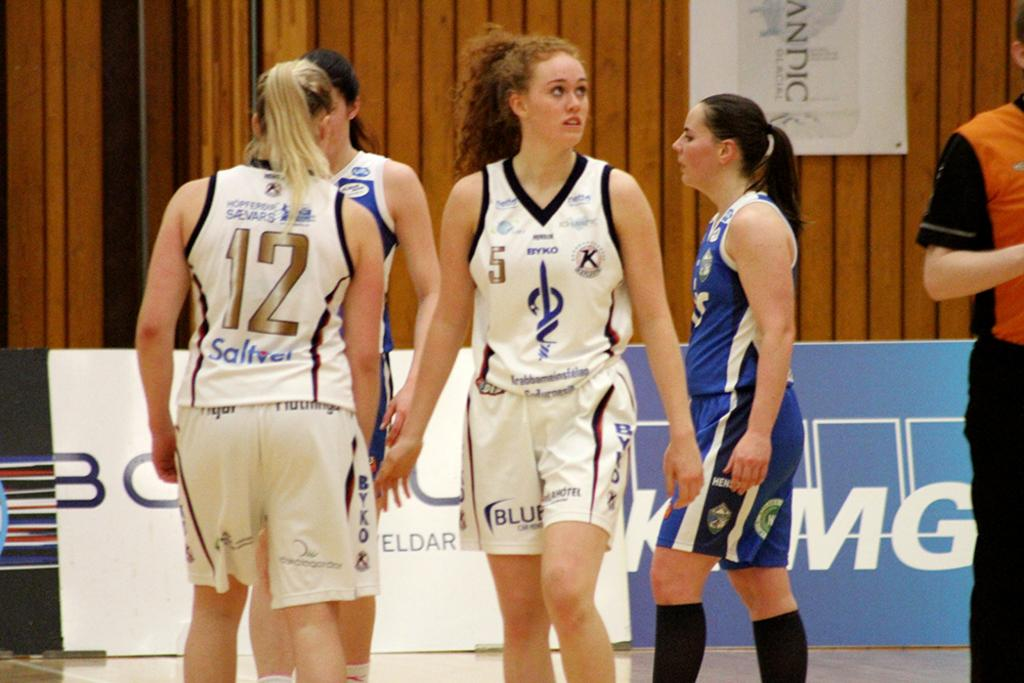<image>
Offer a succinct explanation of the picture presented. number 12 and number 5 of the white team are playing against the blue team 